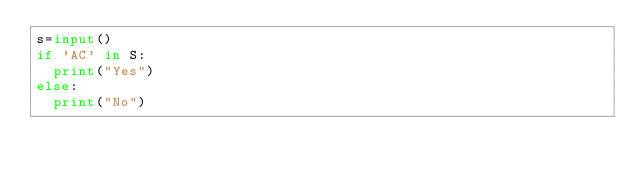<code> <loc_0><loc_0><loc_500><loc_500><_Python_>s=input()
if 'AC' in S:
  print("Yes")
else:
  print("No")</code> 